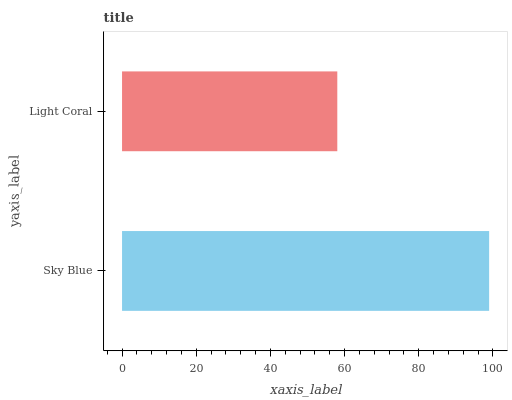Is Light Coral the minimum?
Answer yes or no. Yes. Is Sky Blue the maximum?
Answer yes or no. Yes. Is Light Coral the maximum?
Answer yes or no. No. Is Sky Blue greater than Light Coral?
Answer yes or no. Yes. Is Light Coral less than Sky Blue?
Answer yes or no. Yes. Is Light Coral greater than Sky Blue?
Answer yes or no. No. Is Sky Blue less than Light Coral?
Answer yes or no. No. Is Sky Blue the high median?
Answer yes or no. Yes. Is Light Coral the low median?
Answer yes or no. Yes. Is Light Coral the high median?
Answer yes or no. No. Is Sky Blue the low median?
Answer yes or no. No. 